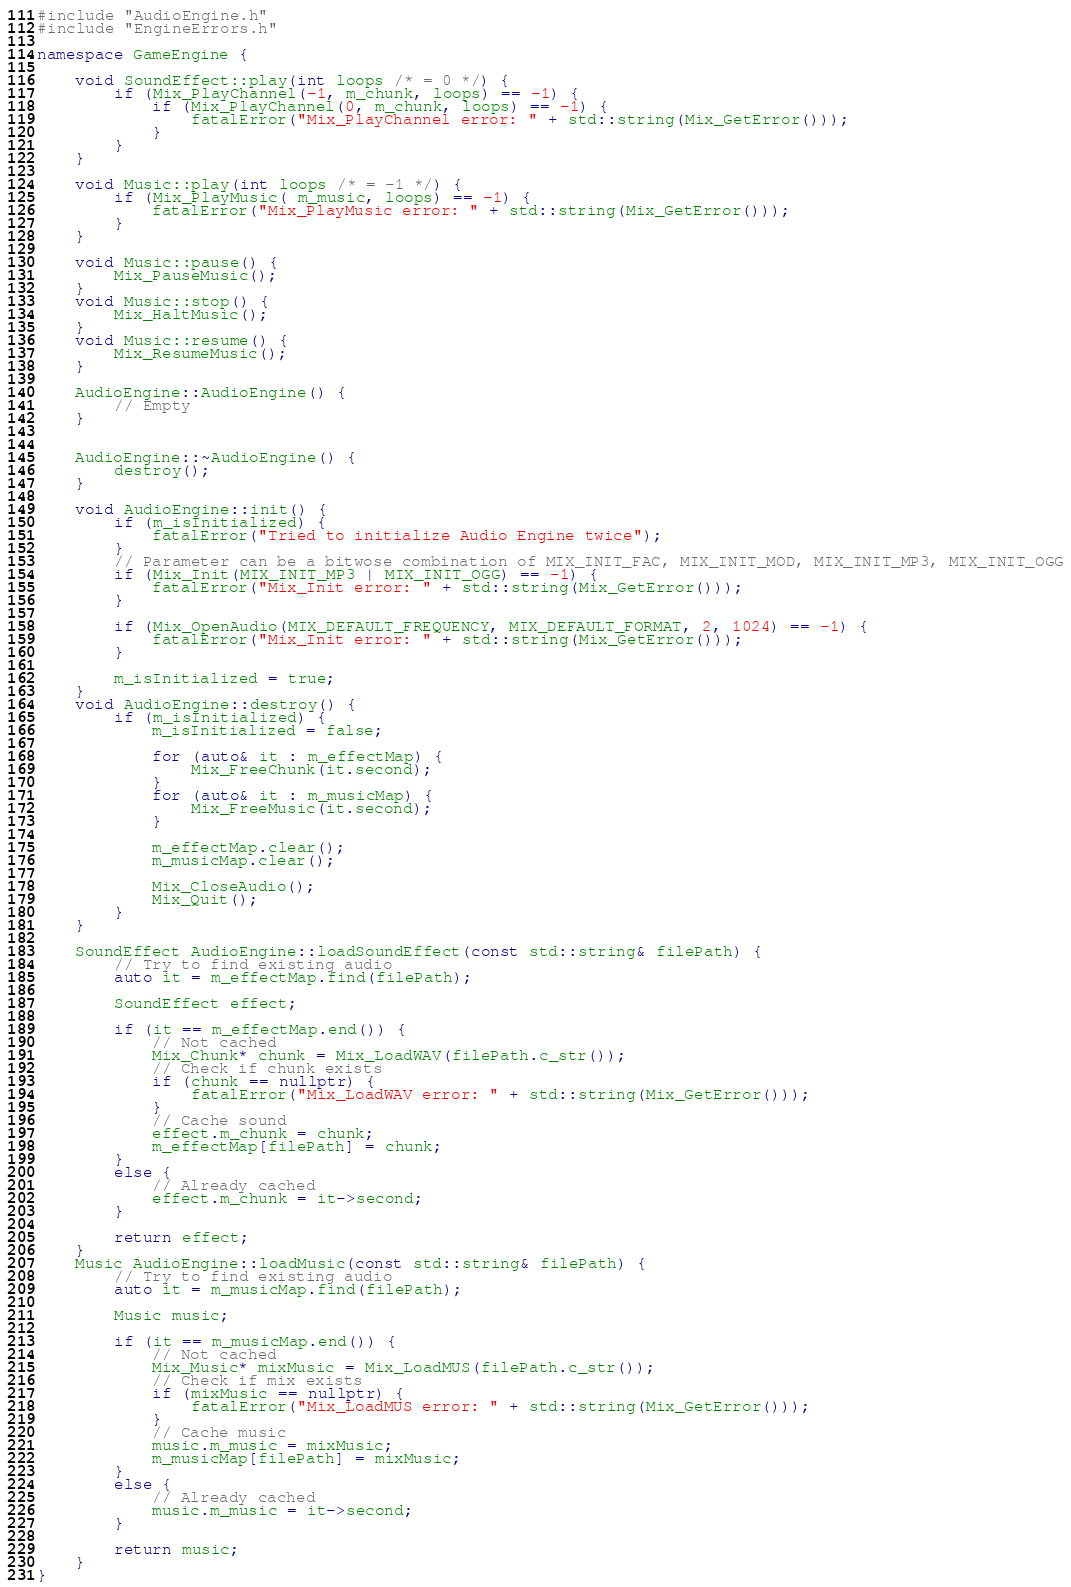<code> <loc_0><loc_0><loc_500><loc_500><_C++_>#include "AudioEngine.h"
#include "EngineErrors.h"

namespace GameEngine {

	void SoundEffect::play(int loops /* = 0 */) {
		if (Mix_PlayChannel(-1, m_chunk, loops) == -1) {
			if (Mix_PlayChannel(0, m_chunk, loops) == -1) {
				fatalError("Mix_PlayChannel error: " + std::string(Mix_GetError()));
			}
		}
	}

	void Music::play(int loops /* = -1 */) {
		if (Mix_PlayMusic( m_music, loops) == -1) {
			fatalError("Mix_PlayMusic error: " + std::string(Mix_GetError()));
		}
	}

	void Music::pause() {
		Mix_PauseMusic();
	}
	void Music::stop() {
		Mix_HaltMusic();
	}
	void Music::resume() {
		Mix_ResumeMusic();
	}

	AudioEngine::AudioEngine() {
		// Empty
	}


	AudioEngine::~AudioEngine() {
		destroy();
	}

	void AudioEngine::init() {
		if (m_isInitialized) {
			fatalError("Tried to initialize Audio Engine twice");
		}
		// Parameter can be a bitwose combination of MIX_INIT_FAC, MIX_INIT_MOD, MIX_INIT_MP3, MIX_INIT_OGG
		if (Mix_Init(MIX_INIT_MP3 | MIX_INIT_OGG) == -1) {
			fatalError("Mix_Init error: " + std::string(Mix_GetError()));
		}

		if (Mix_OpenAudio(MIX_DEFAULT_FREQUENCY, MIX_DEFAULT_FORMAT, 2, 1024) == -1) {
			fatalError("Mix_Init error: " + std::string(Mix_GetError()));
		}

		m_isInitialized = true;
	}
	void AudioEngine::destroy() {
		if (m_isInitialized) {
			m_isInitialized = false;

			for (auto& it : m_effectMap) {
				Mix_FreeChunk(it.second);
			}
			for (auto& it : m_musicMap) {
				Mix_FreeMusic(it.second);
			}

			m_effectMap.clear();
			m_musicMap.clear();

			Mix_CloseAudio();
			Mix_Quit();
		}
	}

	SoundEffect AudioEngine::loadSoundEffect(const std::string& filePath) {
		// Try to find existing audio
		auto it = m_effectMap.find(filePath);

		SoundEffect effect;

		if (it == m_effectMap.end()) {
			// Not cached
			Mix_Chunk* chunk = Mix_LoadWAV(filePath.c_str());
			// Check if chunk exists
			if (chunk == nullptr) {
				fatalError("Mix_LoadWAV error: " + std::string(Mix_GetError()));
			}
			// Cache sound
			effect.m_chunk = chunk;
			m_effectMap[filePath] = chunk;
		}
		else {
			// Already cached
			effect.m_chunk = it->second;
		}
		
		return effect;
	}
	Music AudioEngine::loadMusic(const std::string& filePath) {
		// Try to find existing audio
		auto it = m_musicMap.find(filePath);

		Music music;

		if (it == m_musicMap.end()) {
			// Not cached
			Mix_Music* mixMusic = Mix_LoadMUS(filePath.c_str());
			// Check if mix exists
			if (mixMusic == nullptr) {
				fatalError("Mix_LoadMUS error: " + std::string(Mix_GetError()));
			}
			// Cache music
			music.m_music = mixMusic;
			m_musicMap[filePath] = mixMusic;
		}
		else {
			// Already cached
			music.m_music = it->second;
		}

		return music;
	}
}</code> 